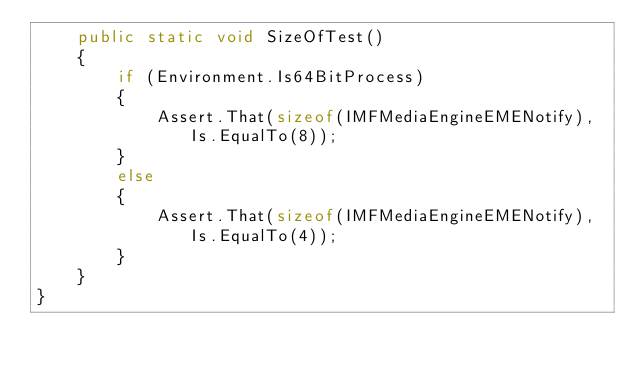Convert code to text. <code><loc_0><loc_0><loc_500><loc_500><_C#_>    public static void SizeOfTest()
    {
        if (Environment.Is64BitProcess)
        {
            Assert.That(sizeof(IMFMediaEngineEMENotify), Is.EqualTo(8));
        }
        else
        {
            Assert.That(sizeof(IMFMediaEngineEMENotify), Is.EqualTo(4));
        }
    }
}
</code> 